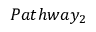<formula> <loc_0><loc_0><loc_500><loc_500>P a t h w a y _ { 2 }</formula> 